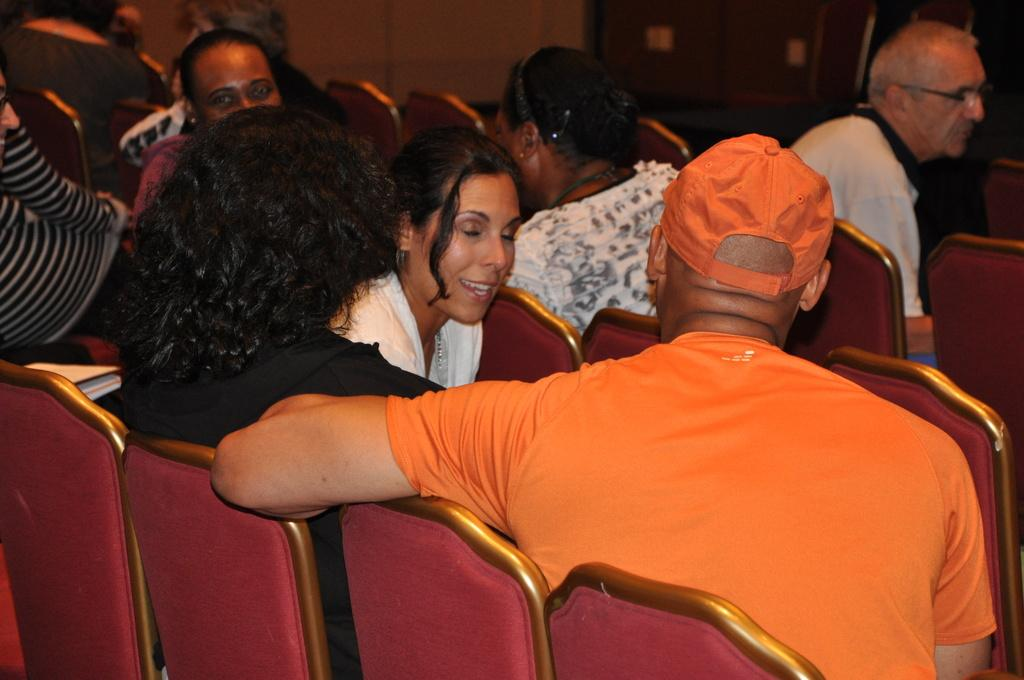How many people are in the image? There are people in the image, but the exact number is not specified. What are the people doing in the image? The people are sitting on chairs in the image. What type of dust can be seen floating around the people in the image? There is no dust visible in the image; it only shows people sitting on chairs. 